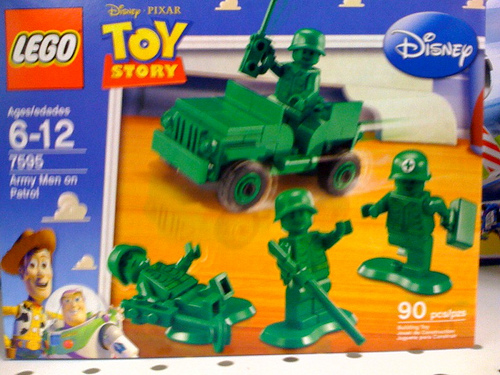<image>
Is there a astronaut on the box? Yes. Looking at the image, I can see the astronaut is positioned on top of the box, with the box providing support. Is the jeep next to the cloud? Yes. The jeep is positioned adjacent to the cloud, located nearby in the same general area. 